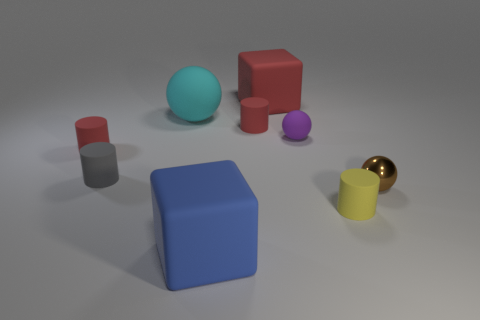Add 1 red matte things. How many objects exist? 10 Subtract all blocks. How many objects are left? 7 Add 1 brown metallic objects. How many brown metallic objects exist? 2 Subtract 0 green cubes. How many objects are left? 9 Subtract all tiny brown things. Subtract all small purple balls. How many objects are left? 7 Add 8 big blue cubes. How many big blue cubes are left? 9 